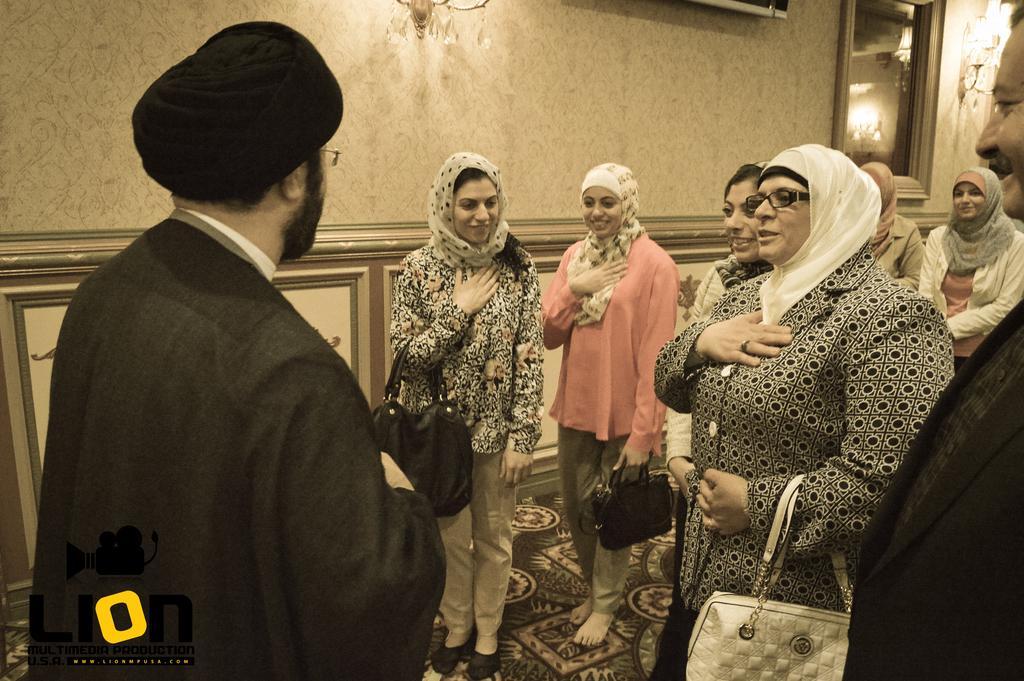Please provide a concise description of this image. In this image we can see many persons standing on the floor and holding bags. In the background we can see light, television and wall. 